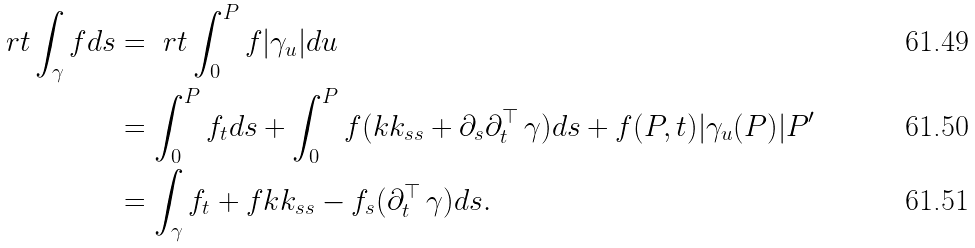Convert formula to latex. <formula><loc_0><loc_0><loc_500><loc_500>\ r { t } \int _ { \gamma } f d s & = \ r { t } \int _ { 0 } ^ { P } f | \gamma _ { u } | d u \\ & = \int _ { 0 } ^ { P } f _ { t } d s + \int _ { 0 } ^ { P } f ( k k _ { s s } + \partial _ { s } \partial ^ { \top } _ { t } \, \gamma ) d s + f ( P , t ) | \gamma _ { u } ( P ) | P ^ { \prime } \\ & = \int _ { \gamma } f _ { t } + f k k _ { s s } - f _ { s } ( \partial ^ { \top } _ { t } \, \gamma ) d s .</formula> 